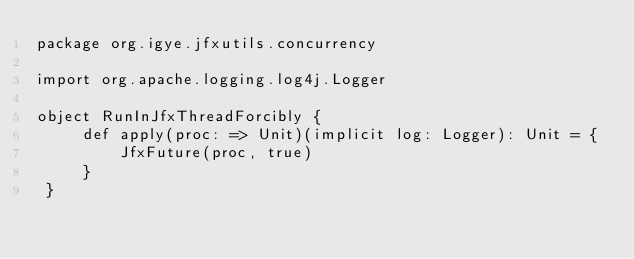<code> <loc_0><loc_0><loc_500><loc_500><_Scala_>package org.igye.jfxutils.concurrency

import org.apache.logging.log4j.Logger

object RunInJfxThreadForcibly {
     def apply(proc: => Unit)(implicit log: Logger): Unit = {
         JfxFuture(proc, true)
     }
 }
</code> 